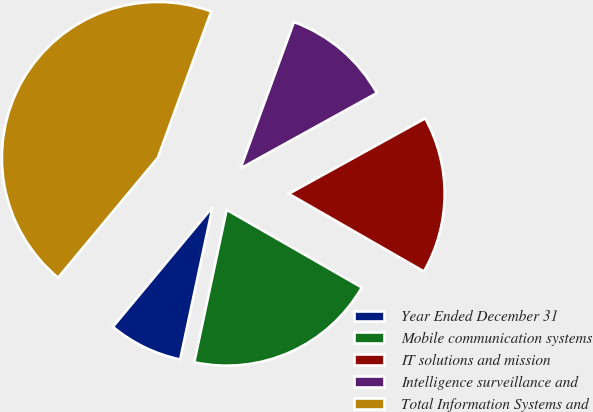Convert chart to OTSL. <chart><loc_0><loc_0><loc_500><loc_500><pie_chart><fcel>Year Ended December 31<fcel>Mobile communication systems<fcel>IT solutions and mission<fcel>Intelligence surveillance and<fcel>Total Information Systems and<nl><fcel>7.71%<fcel>20.03%<fcel>16.34%<fcel>11.39%<fcel>44.53%<nl></chart> 